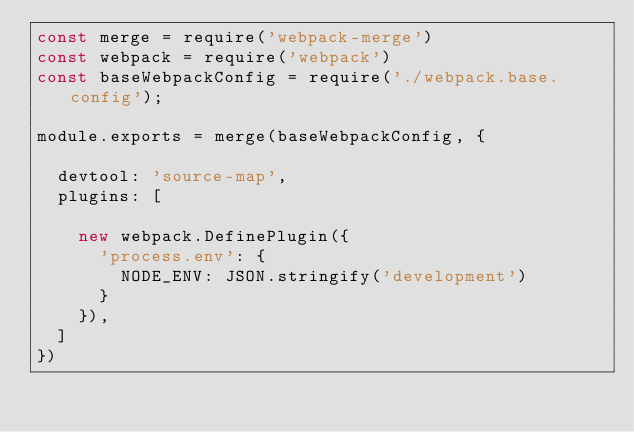<code> <loc_0><loc_0><loc_500><loc_500><_JavaScript_>const merge = require('webpack-merge')
const webpack = require('webpack')
const baseWebpackConfig = require('./webpack.base.config');

module.exports = merge(baseWebpackConfig, {

  devtool: 'source-map',
  plugins: [
    
    new webpack.DefinePlugin({
      'process.env': {
        NODE_ENV: JSON.stringify('development')
      }
    }),
  ]
})



</code> 